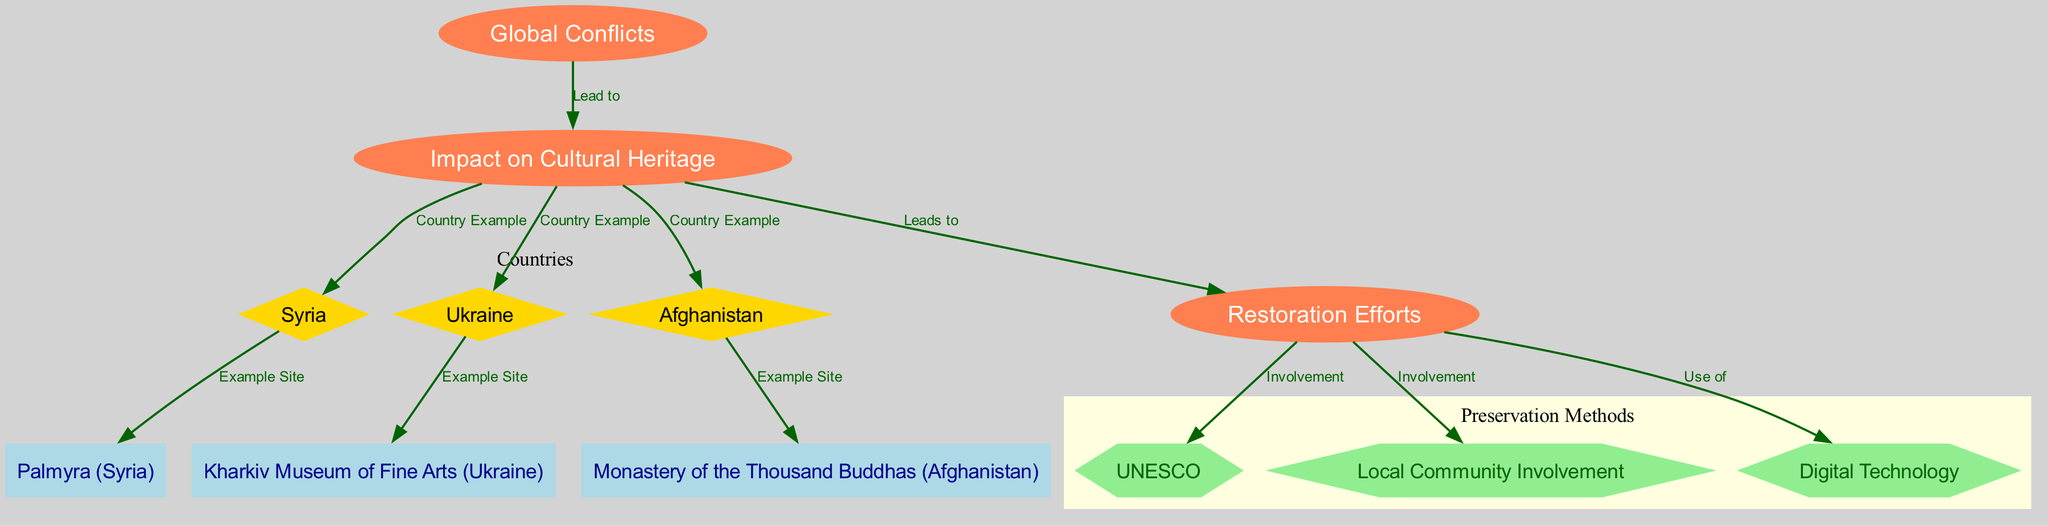What are the countries represented in the diagram? The countries mentioned are linked directly to the "Impact on Cultural Heritage," indicating their examples. They are Syria, Ukraine, and Afghanistan.
Answer: Syria, Ukraine, Afghanistan How many preservation efforts are depicted in the diagram? The diagram illustrates three specific types of preservation efforts: involvement of UNESCO, local community involvement, and the use of digital technology. Each is depicted as a distinct node under the "Preservation Efforts" category.
Answer: Three What is a cultural heritage site example from Syria? The diagram shows that Palmyra is specifically listed as an example site under the node representing Syria.
Answer: Palmyra Which organization is mentioned as involved in restoration efforts? UNESCO is explicitly linked to the preservation efforts node, indicating its involvement in restoration activities.
Answer: UNESCO How do global conflicts affect cultural heritage? The diagram illustrates a direct relationship where "Global Conflicts" lead to an "Impact on Cultural Heritage", establishing a causal link between conflicts and heritage concerns.
Answer: Lead to What relationship does local community involvement have with preservation efforts? The diagram connects local community involvement directly to preservation efforts, showing it as one of the key components in restoring cultural sites.
Answer: Involvement What type of technology is utilized in restoration efforts according to the diagram? Digital technology is specifically identified as a method used in preservation efforts, indicating its importance in the restoration processes.
Answer: Digital Technology Count the number of nodes in the diagram. The diagram consists of 12 nodes representing various entities and connections related to global conflicts and cultural heritage impacts and restoration efforts.
Answer: Twelve What is the connection between cultural heritage impact and Ukraine? The diagram establishes Ukraine as an example country under the "Impact on Cultural Heritage" node, indicating a specific relationship.
Answer: Country Example 